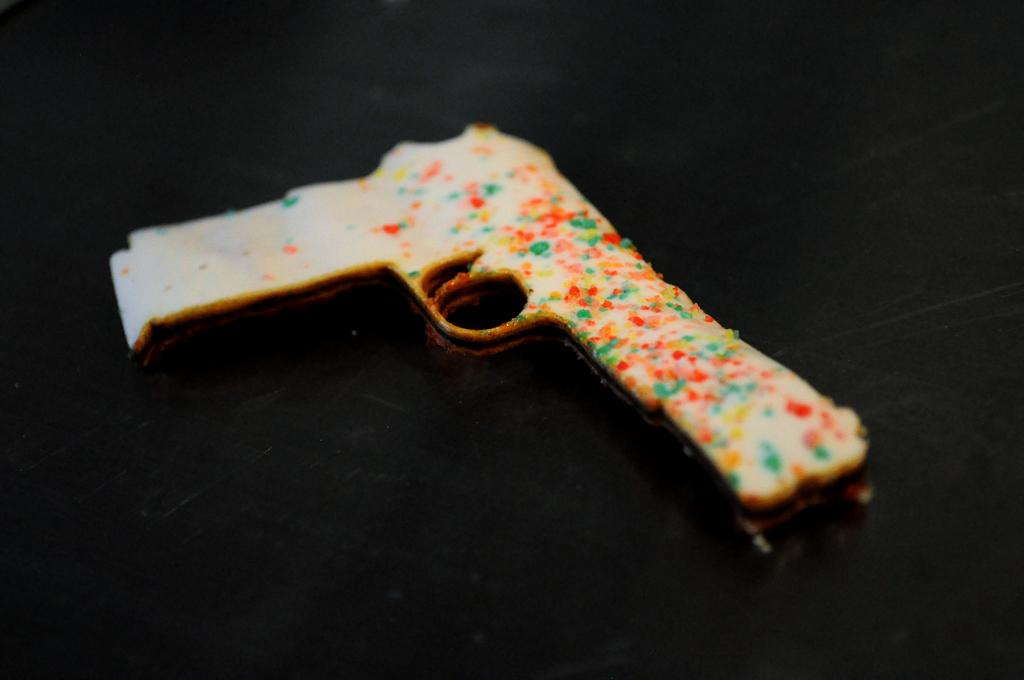What is the main subject of the image? There is a food item in the image. Can you describe the shape of the food item? The food item is in the shape of a gun. What is there a committee meeting taking place in the image? There is no indication of a committee meeting or any people in the image; it only features a food item in the shape of a gun. 